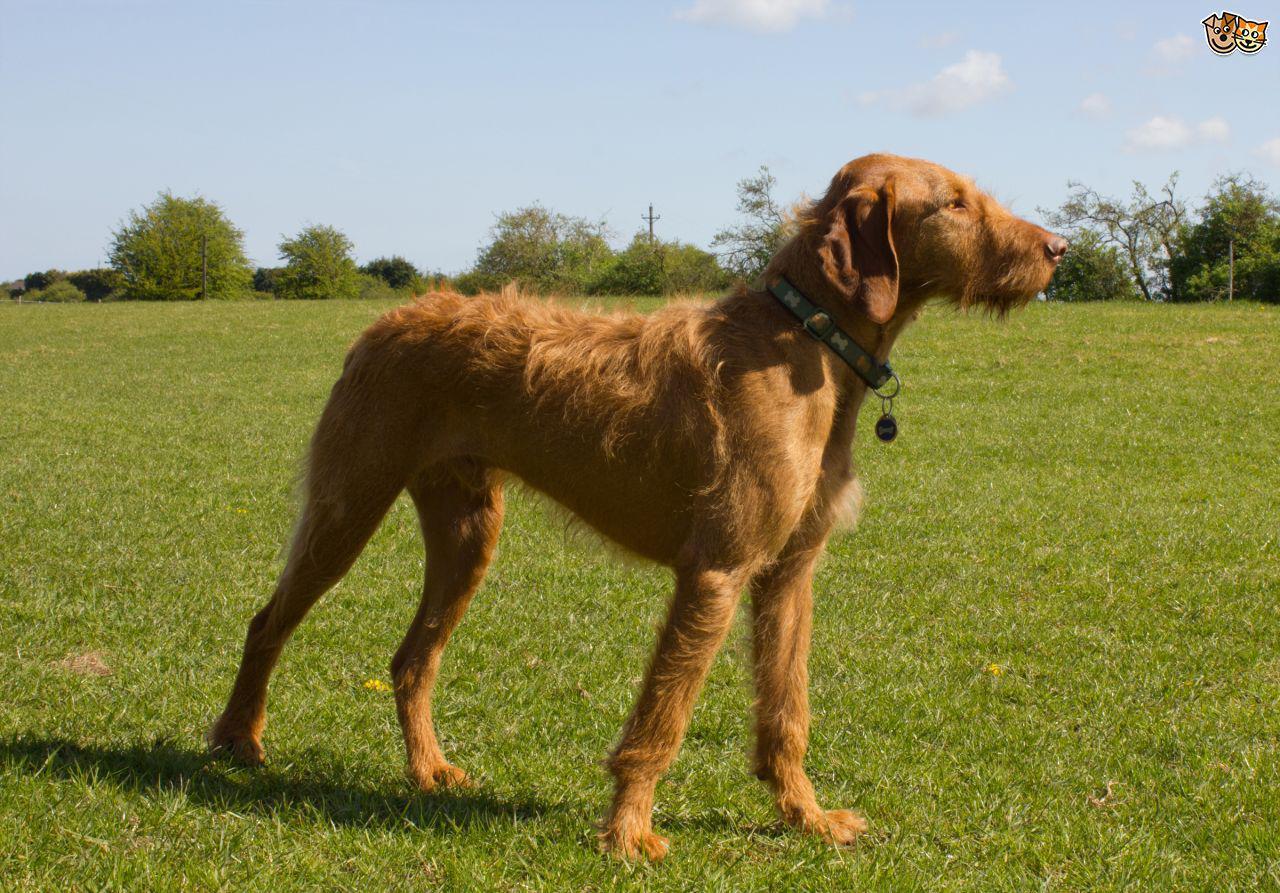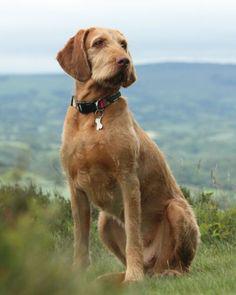The first image is the image on the left, the second image is the image on the right. Evaluate the accuracy of this statement regarding the images: "In one image, a dog is standing with one of its paws lifted up off the ground.". Is it true? Answer yes or no. No. The first image is the image on the left, the second image is the image on the right. Given the left and right images, does the statement "There is a total of two dogs with one sitting and one standing." hold true? Answer yes or no. Yes. 